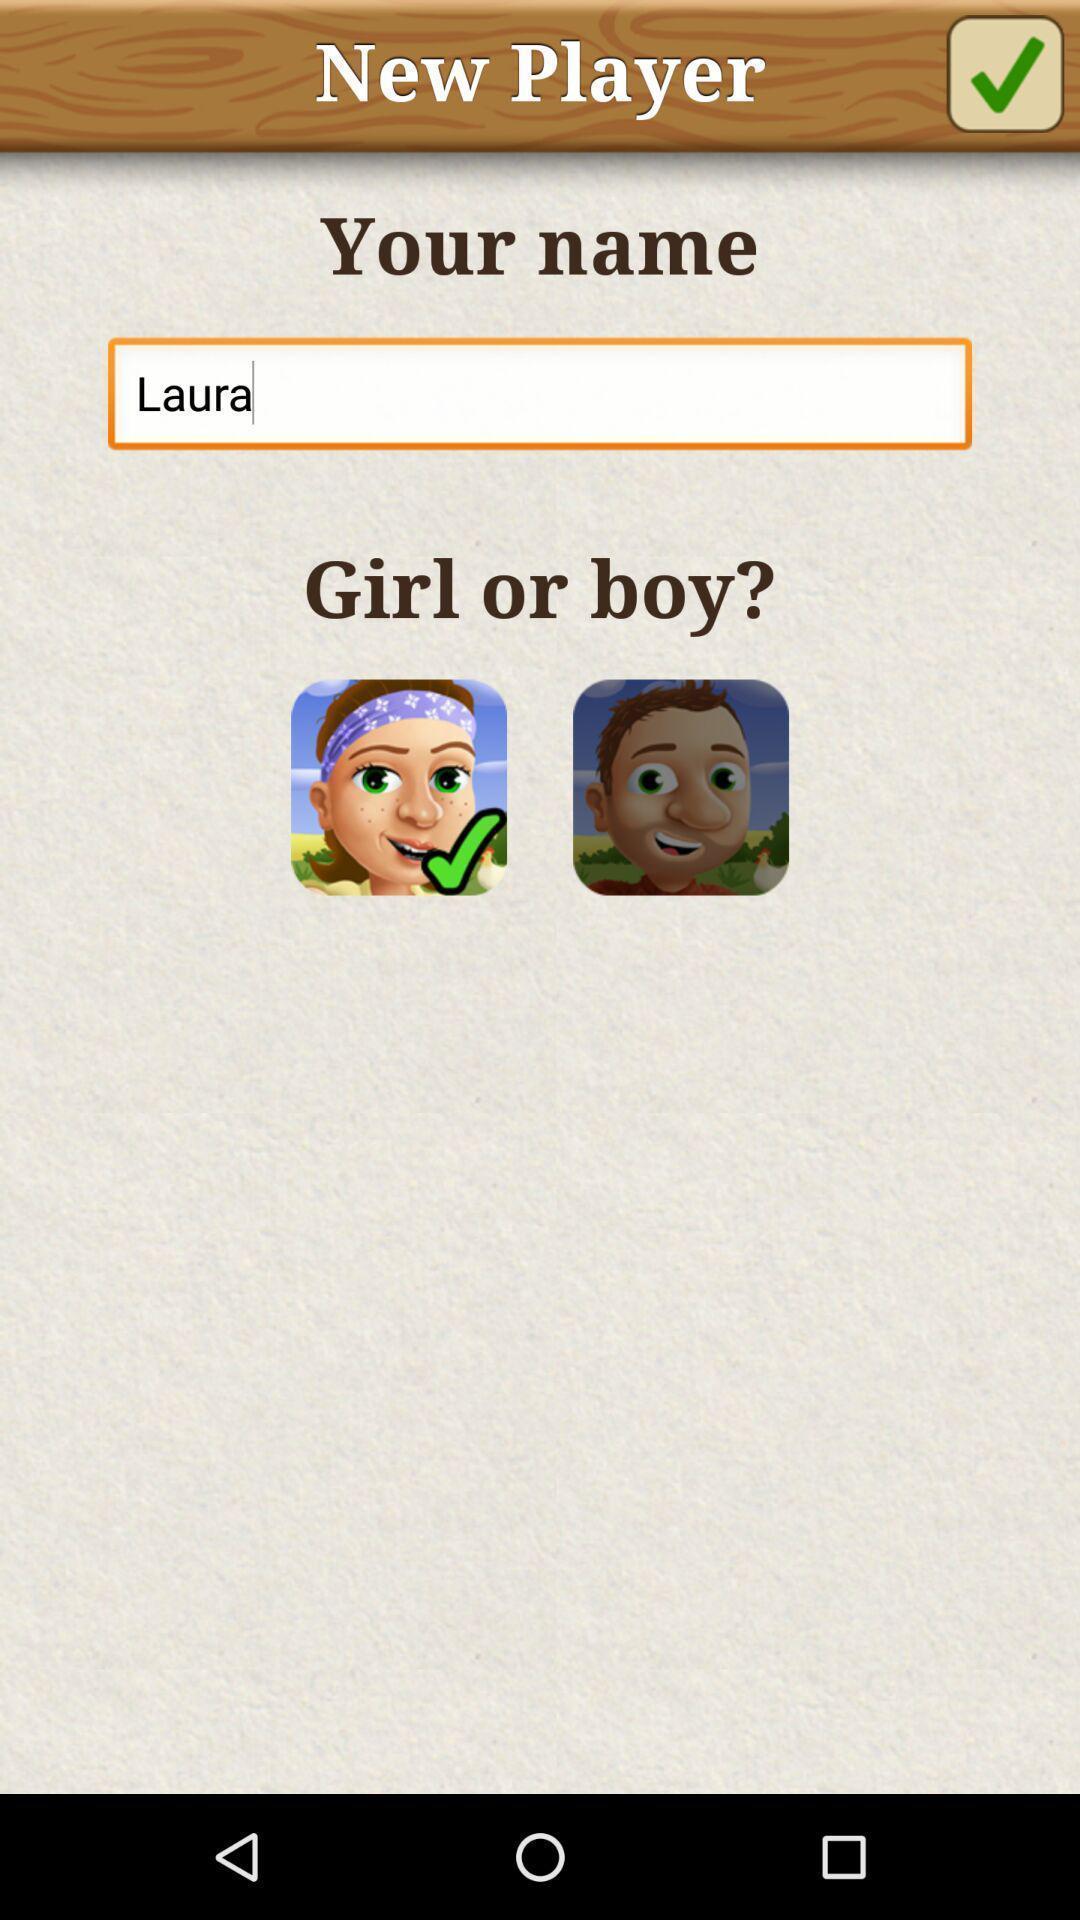What details can you identify in this image? Page displaying to select a gender in application. 